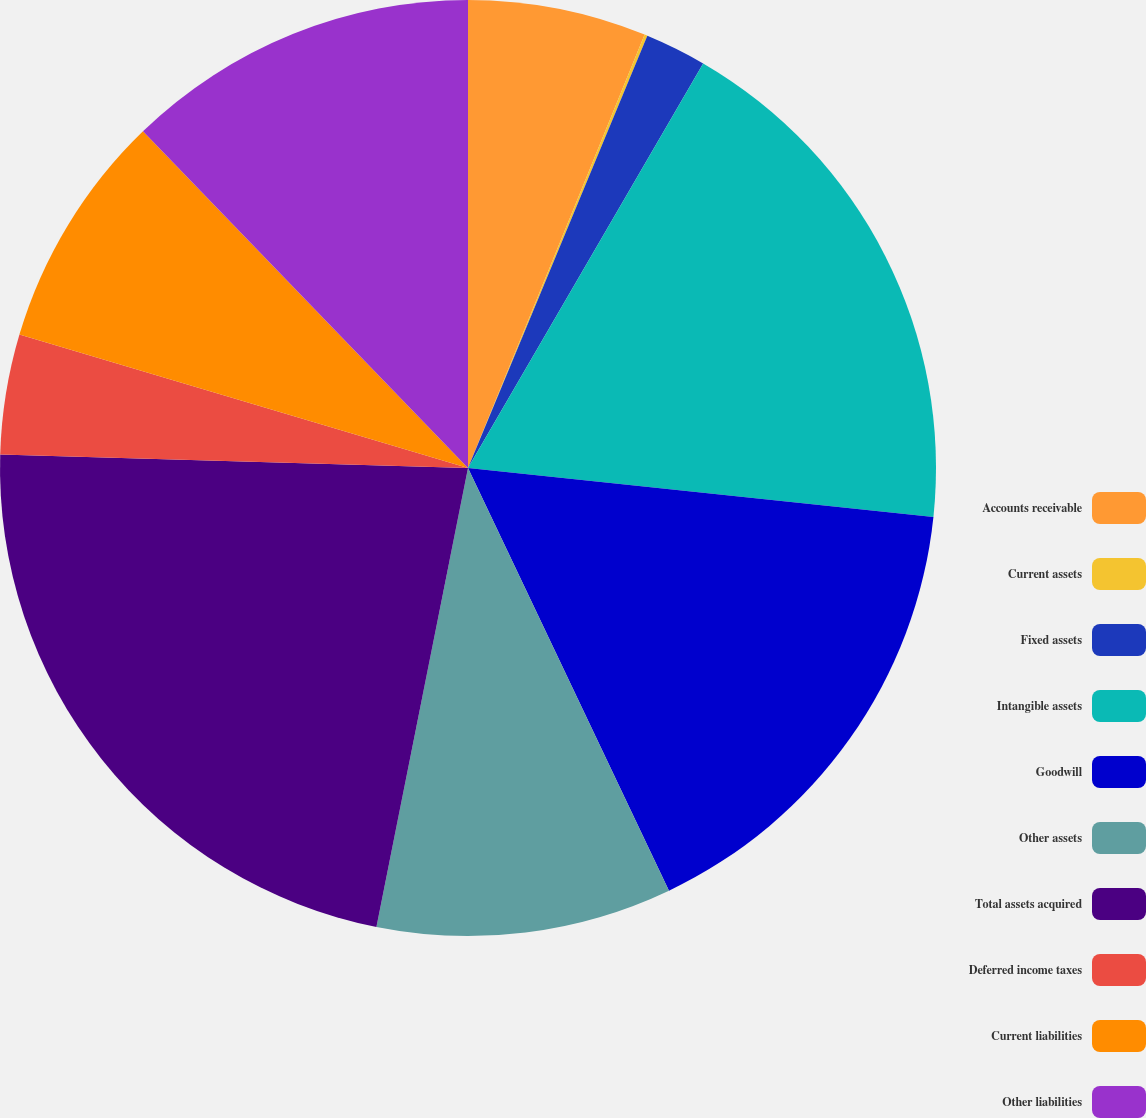<chart> <loc_0><loc_0><loc_500><loc_500><pie_chart><fcel>Accounts receivable<fcel>Current assets<fcel>Fixed assets<fcel>Intangible assets<fcel>Goodwill<fcel>Other assets<fcel>Total assets acquired<fcel>Deferred income taxes<fcel>Current liabilities<fcel>Other liabilities<nl><fcel>6.16%<fcel>0.1%<fcel>2.12%<fcel>18.29%<fcel>16.27%<fcel>10.2%<fcel>22.33%<fcel>4.14%<fcel>8.18%<fcel>12.22%<nl></chart> 